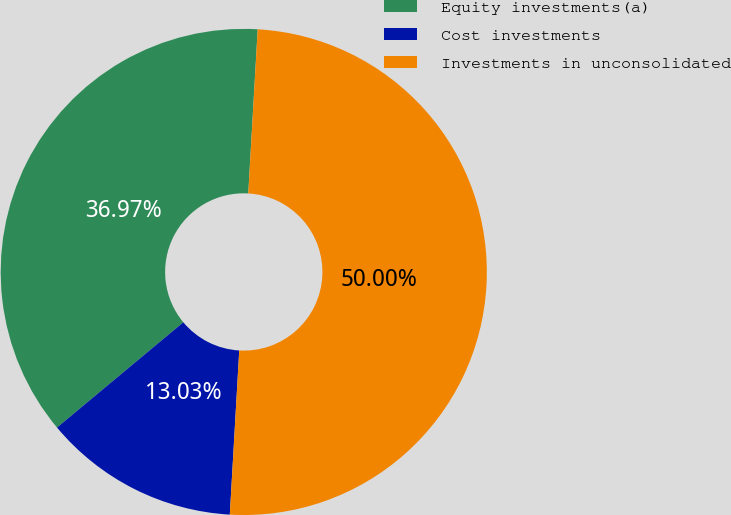Convert chart to OTSL. <chart><loc_0><loc_0><loc_500><loc_500><pie_chart><fcel>Equity investments(a)<fcel>Cost investments<fcel>Investments in unconsolidated<nl><fcel>36.97%<fcel>13.03%<fcel>50.0%<nl></chart> 